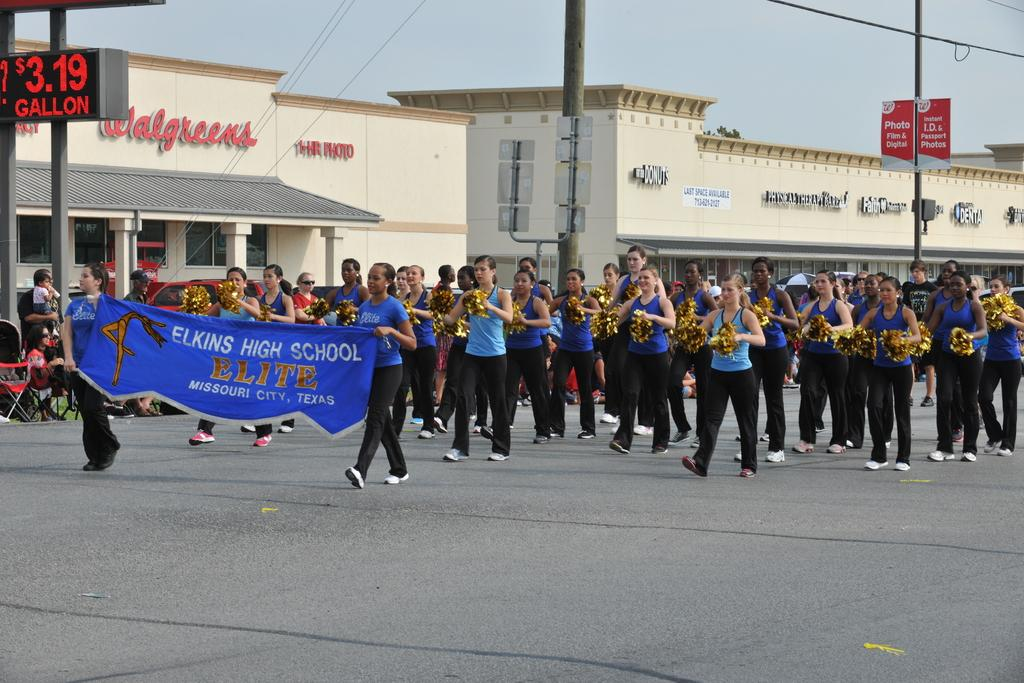How many people are in the image? There is a group of people in the image. What are two persons in the group doing? Two persons are holding a banner. What type of structures can be seen in the image? There are buildings in the image. What objects are present in the image that might be used for support or display? There are poles and name boards present in the image. What type of infrastructure is visible in the image? Cables are visible in the image. What is visible in the background of the image? The sky is visible in the background of the image. What type of debt is being discussed by the group of people in the image? There is no indication of any debt being discussed in the image. Can you tell me how many buttons are visible on the clothing of the people in the image? There is no information about buttons on the clothing of the people in the image. 